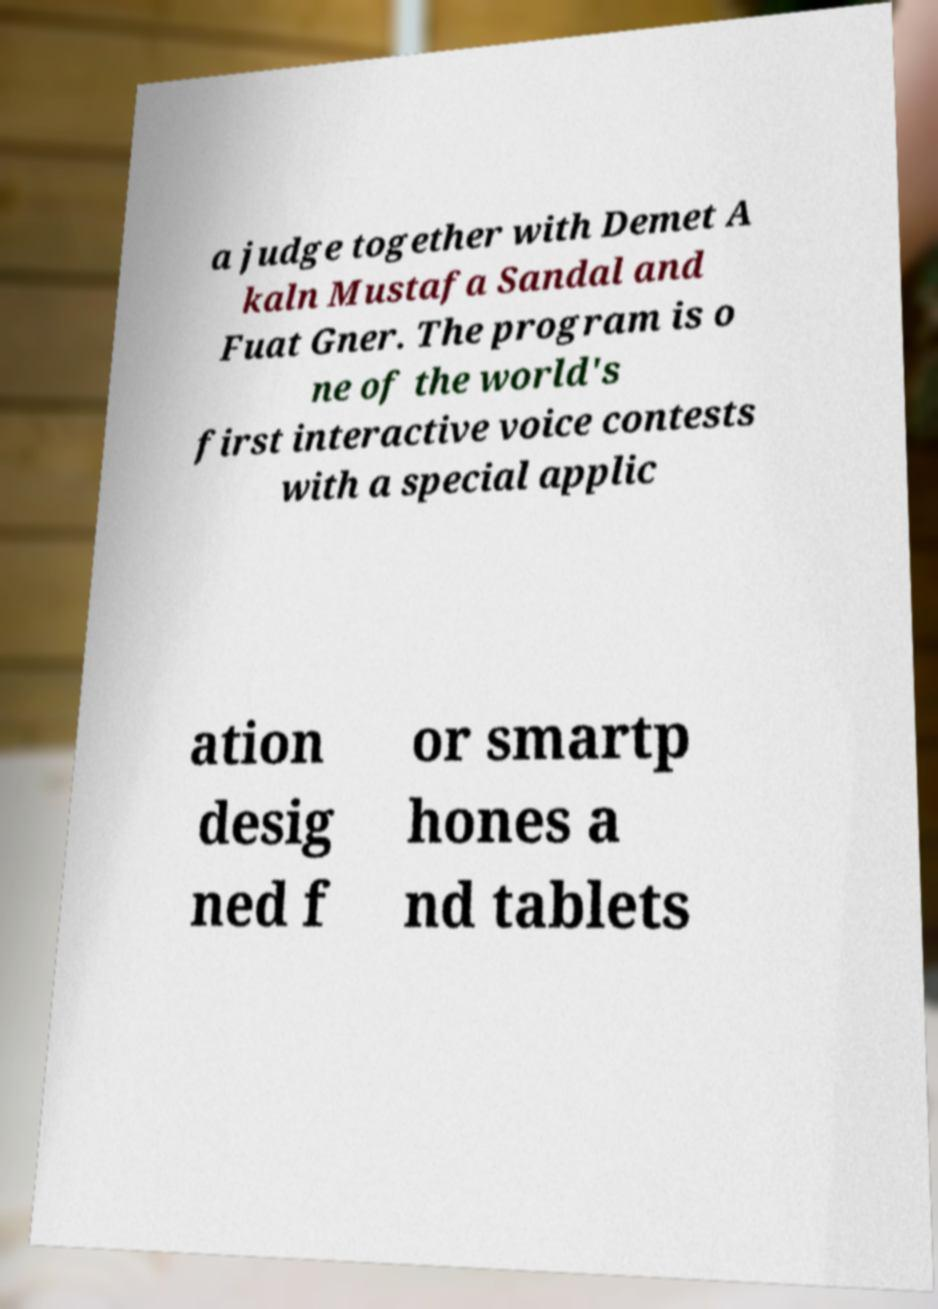Please read and relay the text visible in this image. What does it say? a judge together with Demet A kaln Mustafa Sandal and Fuat Gner. The program is o ne of the world's first interactive voice contests with a special applic ation desig ned f or smartp hones a nd tablets 